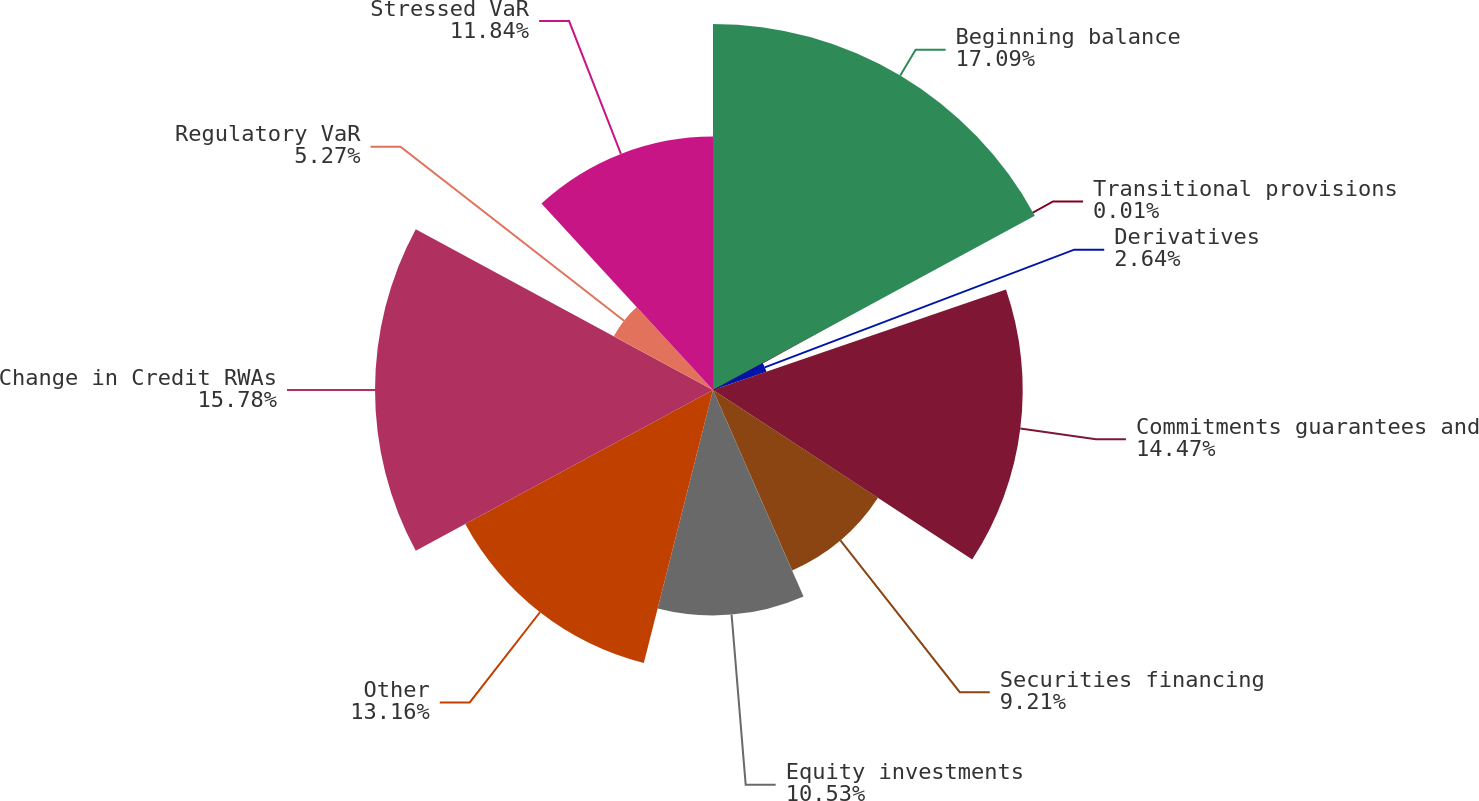<chart> <loc_0><loc_0><loc_500><loc_500><pie_chart><fcel>Beginning balance<fcel>Transitional provisions<fcel>Derivatives<fcel>Commitments guarantees and<fcel>Securities financing<fcel>Equity investments<fcel>Other<fcel>Change in Credit RWAs<fcel>Regulatory VaR<fcel>Stressed VaR<nl><fcel>17.1%<fcel>0.01%<fcel>2.64%<fcel>14.47%<fcel>9.21%<fcel>10.53%<fcel>13.16%<fcel>15.79%<fcel>5.27%<fcel>11.84%<nl></chart> 